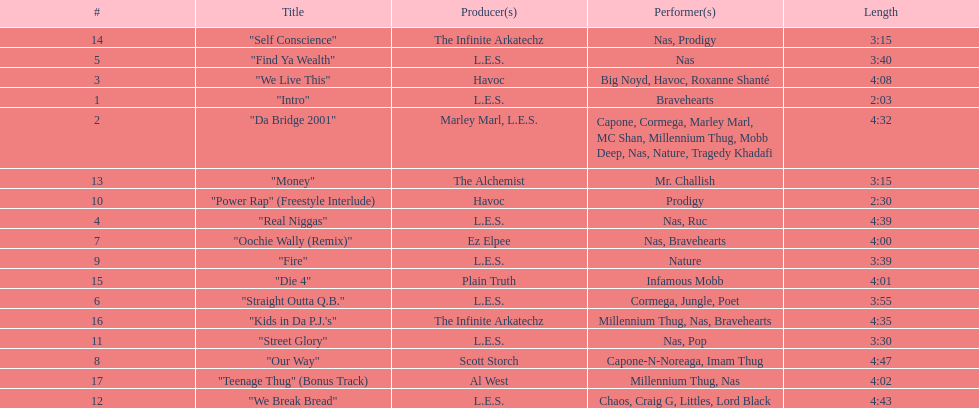Who produced the last track of the album? Al West. 